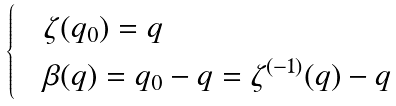<formula> <loc_0><loc_0><loc_500><loc_500>\begin{cases} & \zeta ( q _ { 0 } ) = q \\ & \beta ( q ) = q _ { 0 } - q = \zeta ^ { ( - 1 ) } ( q ) - q \end{cases}</formula> 